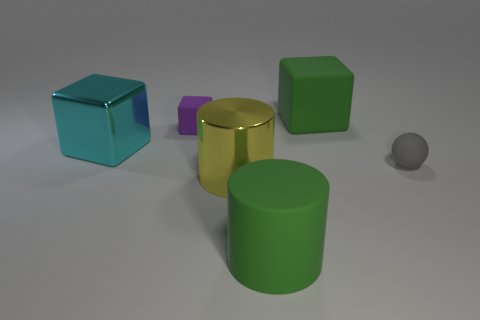There is a big thing that is both behind the yellow metallic cylinder and on the right side of the purple rubber thing; what color is it?
Offer a very short reply. Green. What is the material of the large green object in front of the small gray object?
Your answer should be compact. Rubber. What is the size of the yellow cylinder?
Make the answer very short. Large. What number of blue objects are either rubber things or blocks?
Ensure brevity in your answer.  0. There is a green thing that is behind the large cylinder that is right of the yellow metallic thing; what size is it?
Ensure brevity in your answer.  Large. There is a rubber sphere; is its color the same as the big block that is in front of the green block?
Provide a short and direct response. No. How many other things are the same material as the small gray thing?
Make the answer very short. 3. Are there the same number of big blue things and big metallic things?
Your response must be concise. No. The purple object that is made of the same material as the small gray object is what shape?
Ensure brevity in your answer.  Cube. Are there any other things of the same color as the big shiny cylinder?
Provide a succinct answer. No. 